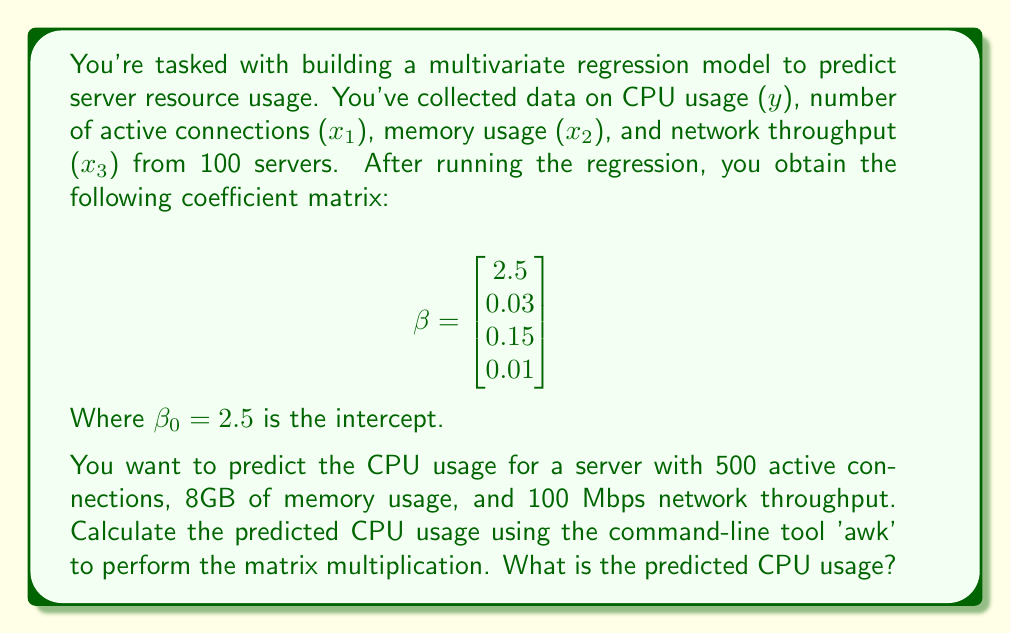Give your solution to this math problem. To solve this problem, we need to use the multivariate regression equation:

$$y = \beta_0 + \beta_1x_1 + \beta_2x_2 + \beta_3x_3$$

Where:
- $y$ is the predicted CPU usage
- $\beta_0$ is the intercept (2.5)
- $\beta_1, \beta_2, \beta_3$ are the coefficients for active connections, memory usage, and network throughput respectively
- $x_1, x_2, x_3$ are the values for active connections (500), memory usage (8), and network throughput (100)

We can rewrite this as a matrix multiplication:

$$y = [1, x_1, x_2, x_3] \cdot \beta$$

To calculate this using awk, we can use the following command:

```
echo "1 500 8 100" | awk '{print $1*2.5 + $2*0.03 + $3*0.15 + $4*0.01}'
```

Let's break down the calculation:

1. Intercept: $1 \cdot 2.5 = 2.5$
2. Active connections: $500 \cdot 0.03 = 15$
3. Memory usage: $8 \cdot 0.15 = 1.2$
4. Network throughput: $100 \cdot 0.01 = 1$

Sum these values:

$$y = 2.5 + 15 + 1.2 + 1 = 19.7$$

Therefore, the predicted CPU usage is 19.7%.
Answer: 19.7% 